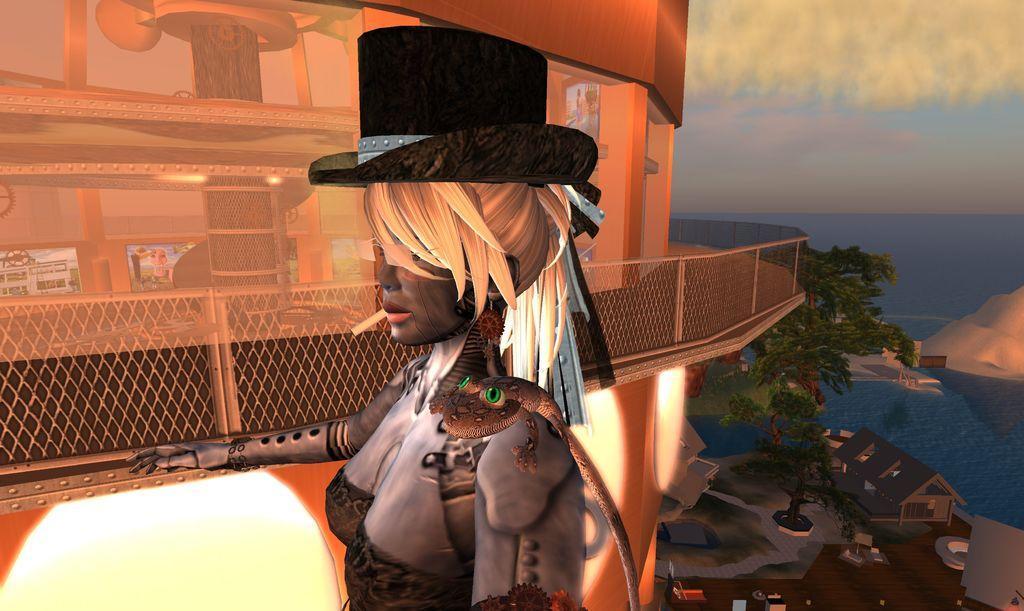Describe this image in one or two sentences. This is an animated image, in this image there is a lady, on that lady there is a lizard, in the background there is a building, trees, houses, sea and the sky. 